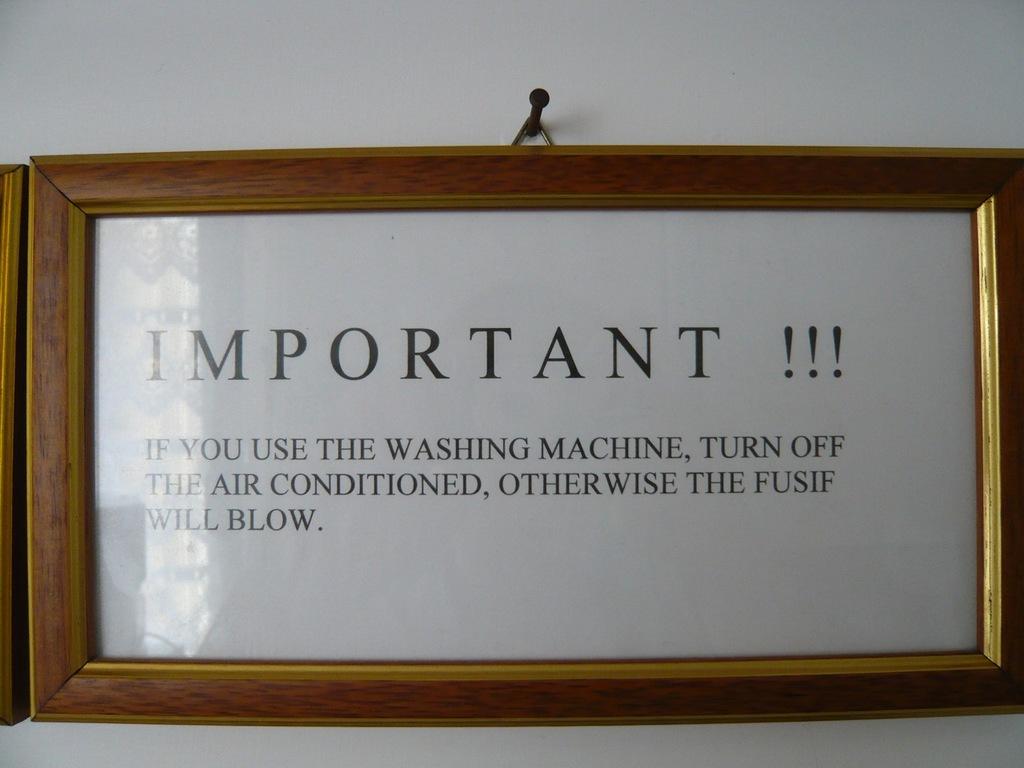How many explanation marks are there?
Your answer should be very brief. Three. 